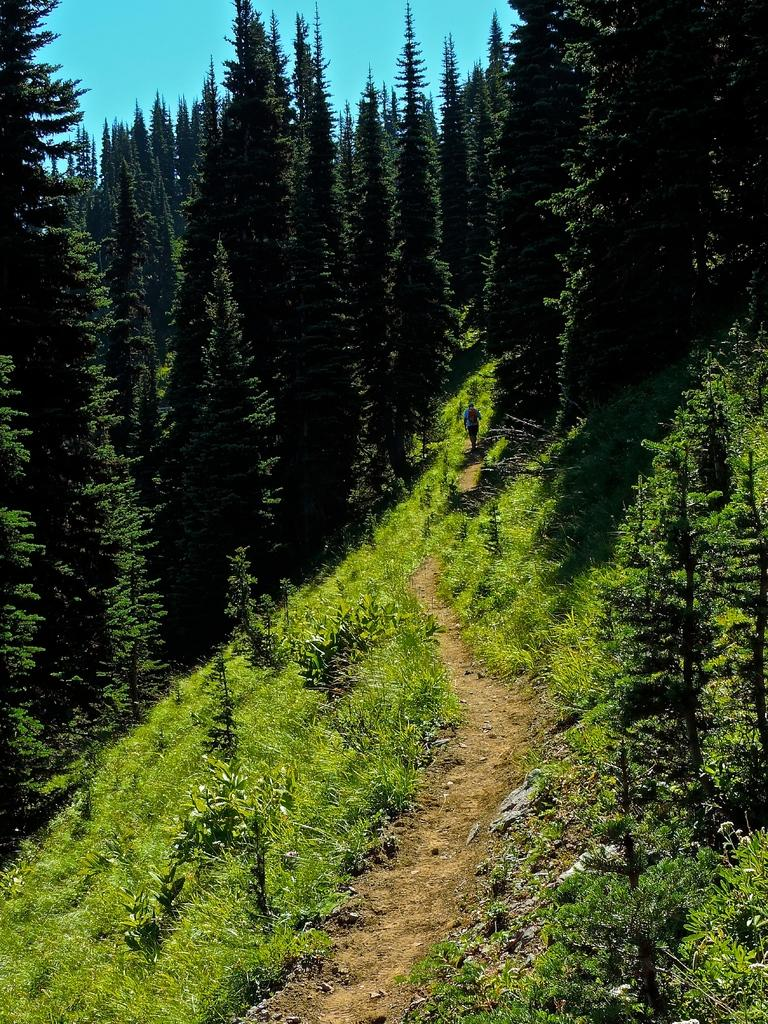What type of vegetation can be seen in the image? There are trees and plants in the image. What is visible at the top of the image? The sky is visible at the top of the image. Where is the desk located in the image? There is no desk present in the image. What type of cast can be seen on the plants in the image? There is no cast on the plants in the image; they are not injured or in need of support. 